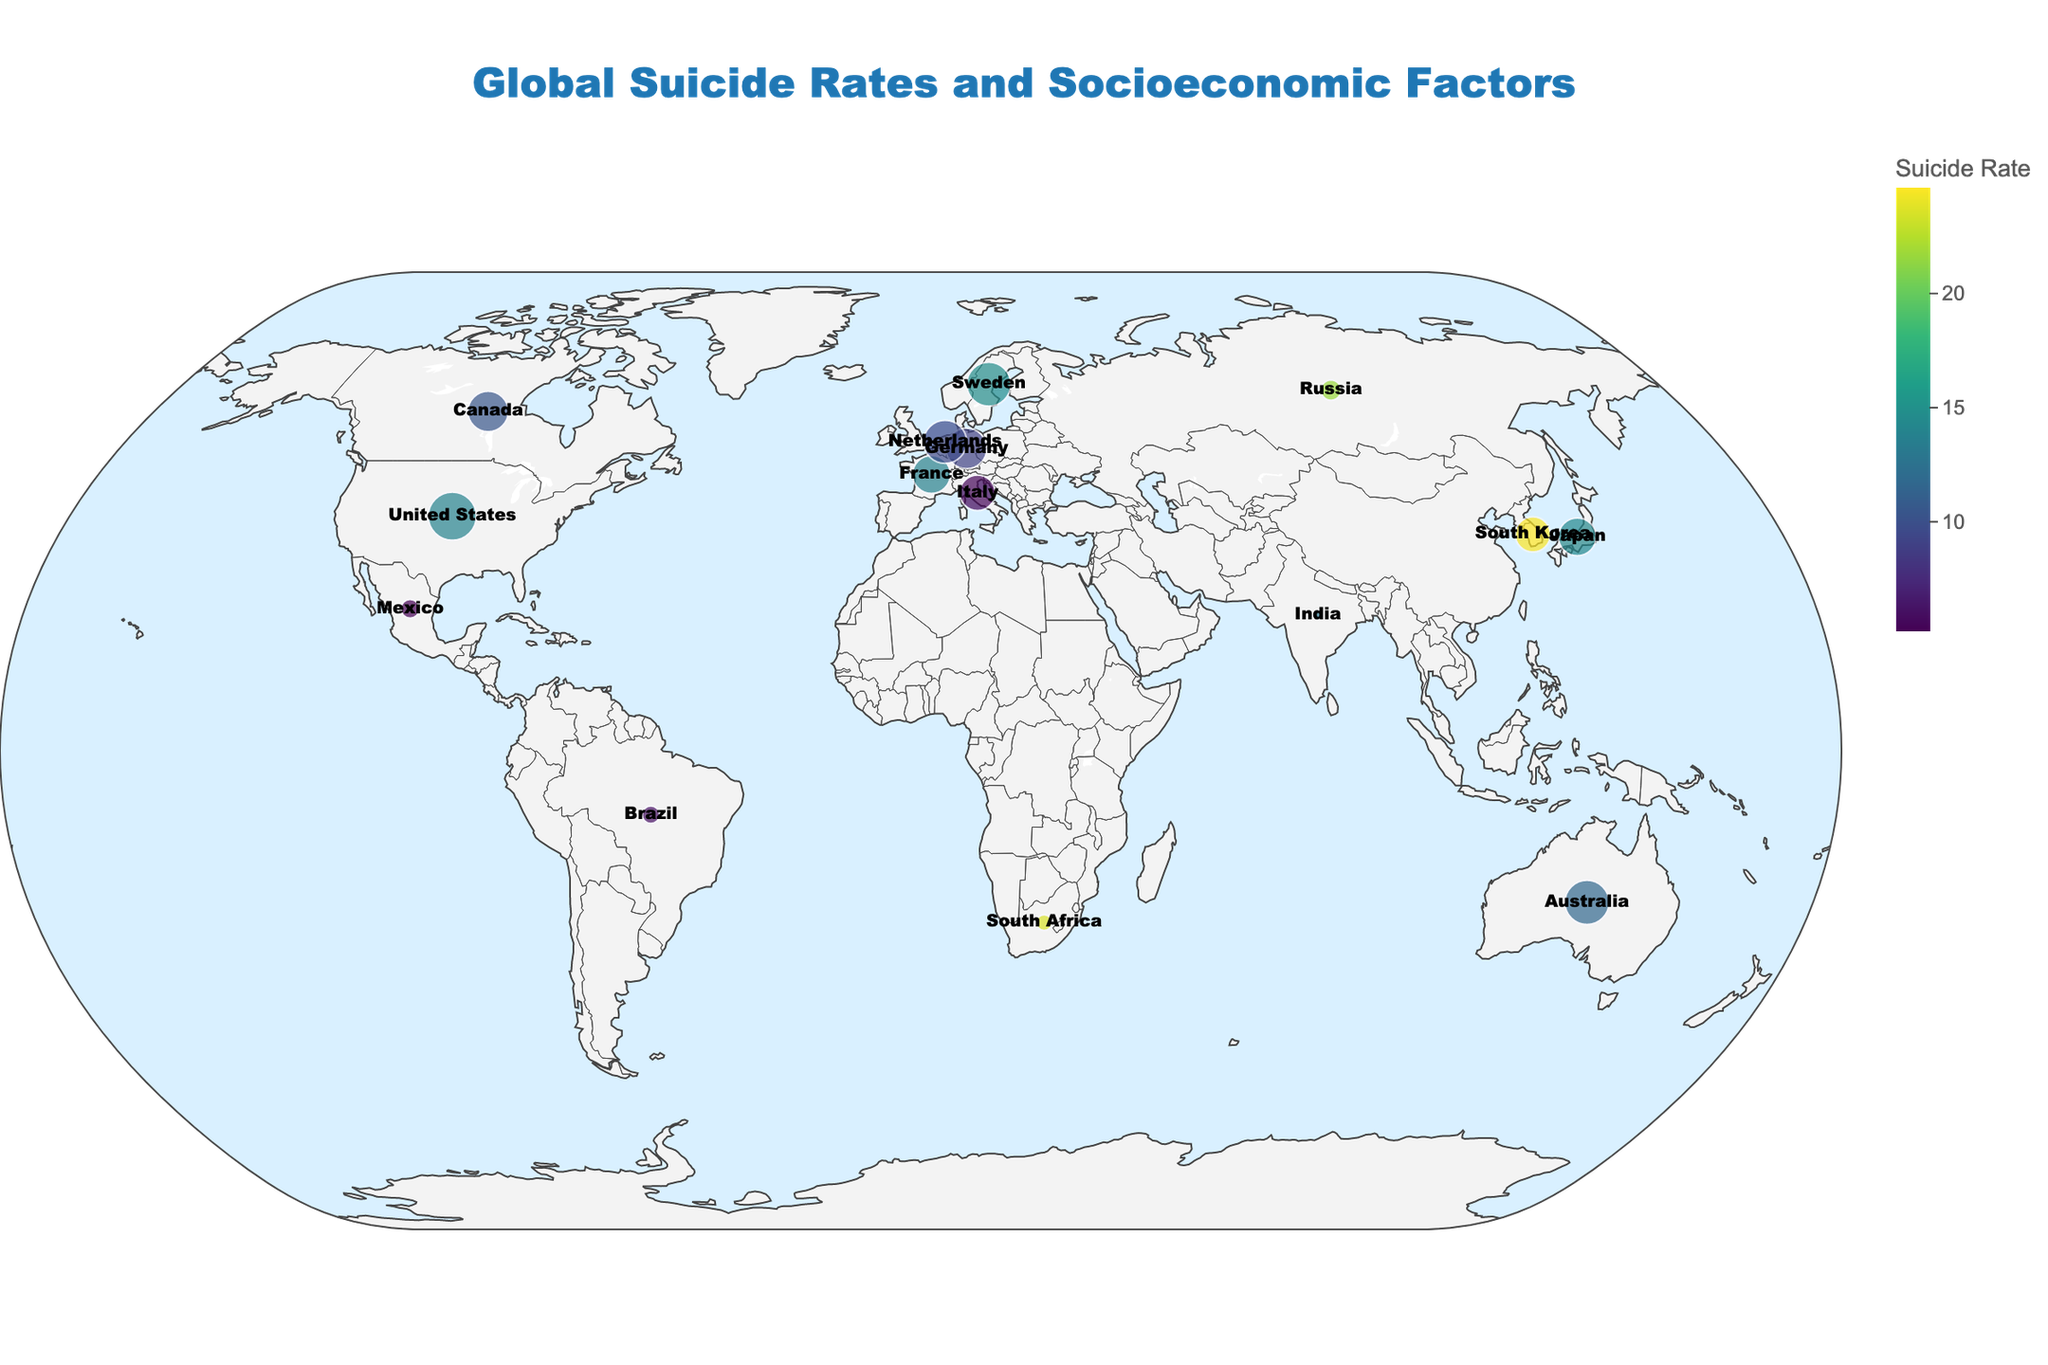What is the title of the plot? The title of the plot is positioned prominently at the top. It provides a summary of the content being visualized.
Answer: Global Suicide Rates and Socioeconomic Factors Which region has the highest suicide rate and what is that rate? The color scale helps us identify the highest suicide rate since darker colors represent higher rates. By hovering or looking at the color legend and corresponding regions, we find the region with the highest rate. In this case, South Korea has the highest suicide rate.
Answer: South Korea; 24.6 How does the GDP per capita affect the size of the markers on the plot? The size of the markers is proportional to the GDP per capita. Regions with higher GDP per capita have larger markers, as shown in the data explanation section. Observing the plot reveals that larger markers like the United States and Australia signify higher GDP per capita.
Answer: Higher GDP per capita results in larger markers What is the color scale used to represent the suicide rate in the plot? The plot employs a color scale to indicate suicide rates, transitioning from light to dark. The specific color scheme used is Viridis, which ranges from light shades for lower rates to darker shades for higher rates.
Answer: Viridis Which two regions have the closest suicide rates, and what are those rates? To determine this, we compare the suicide rates of all regions. The two closest suicide rates are for the United States (13.9) and France (13.8).
Answer: United States; 13.9 and France; 13.8 Which region has the highest mental health spending, and what is its suicide rate? By examining the data points on the plot and identifying the region with the largest mental health spending (thicker segments in the marker), we find that Sweden has the highest mental health spending. Observing its color and hovering reveals its suicide rate.
Answer: Sweden; 14.7 What is the average suicide rate of all regions depicted on the plot? To find the average, sum the suicide rates of all regions and divide by the total number of regions. (13.9 + 14.3 + 21.6 + 24.6 + 9.1 + 6.1 + 12.7 + 11.7 + 13.8 + 23.5 + 10.4 + 14.7 + 5.2 + 5.5 + 9.6) / 15 = 13.22
Answer: 13.22 Which region has the highest unemployment rate and what is its corresponding GDP per capita? The plot allows us to hover over regions to see data. South Africa has the highest unemployment rate. Examining the additional information provided by hovering, we see the GDP per capita for South Africa.
Answer: South Africa; $6994 How does mental health spending correlate with suicide rates based on the plot? To understand the correlation, review the plots of regions with high and low mental health spending. Higher mental health spending regions (like Canada and Germany) often have lower suicide rates compared to regions with low mental health spending (like South Africa and India) hinting at an inverse correlation.
Answer: Generally inversely correlated 